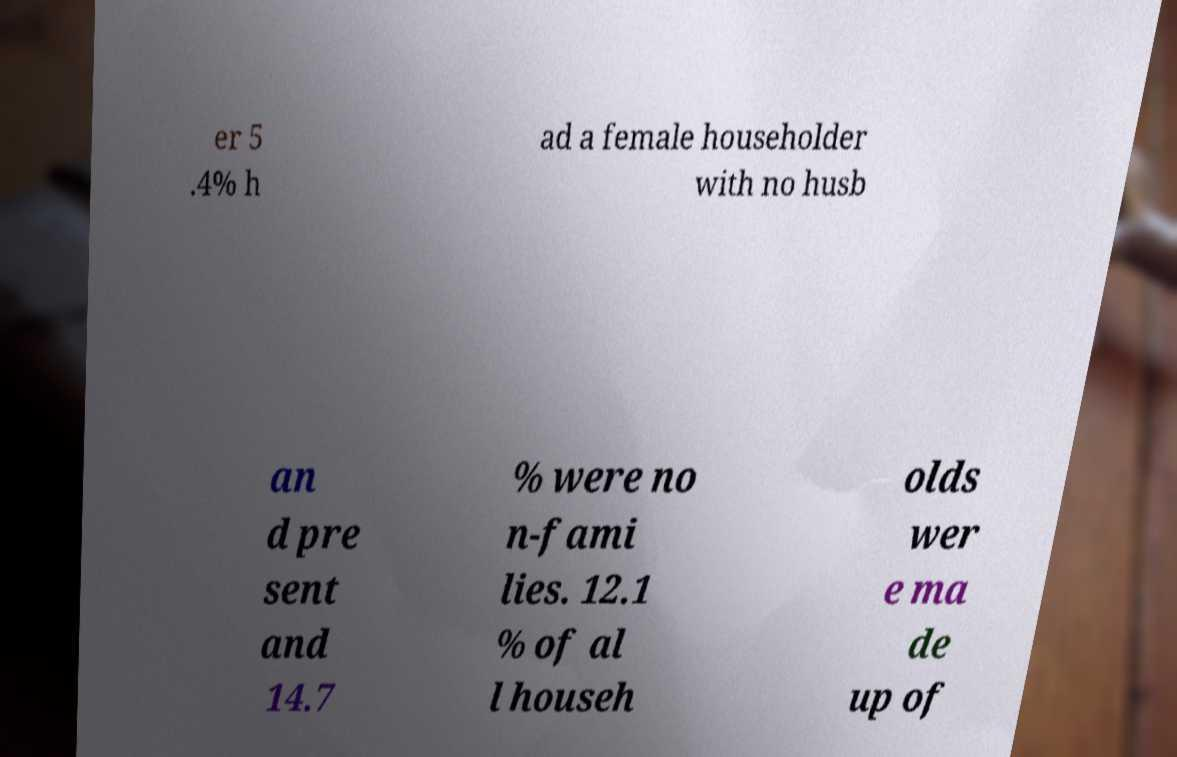What messages or text are displayed in this image? I need them in a readable, typed format. er 5 .4% h ad a female householder with no husb an d pre sent and 14.7 % were no n-fami lies. 12.1 % of al l househ olds wer e ma de up of 